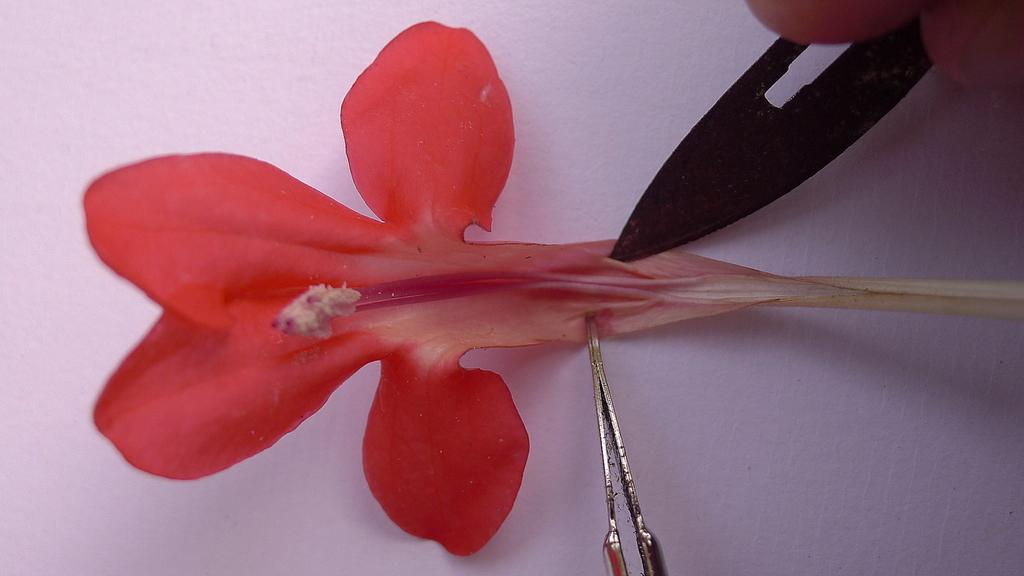What objects are present in the image? There are two tools and an object in the image. Where are the tools located? The tools are on a red flower. Can you describe the person's hand in the image? A person's hand is visible in the image. What type of toothpaste is being used by the person in the image? There is no toothpaste present in the image. How many fingers are visible on the person's hand in the image? The number of fingers visible on the person's hand cannot be determined from the image. 